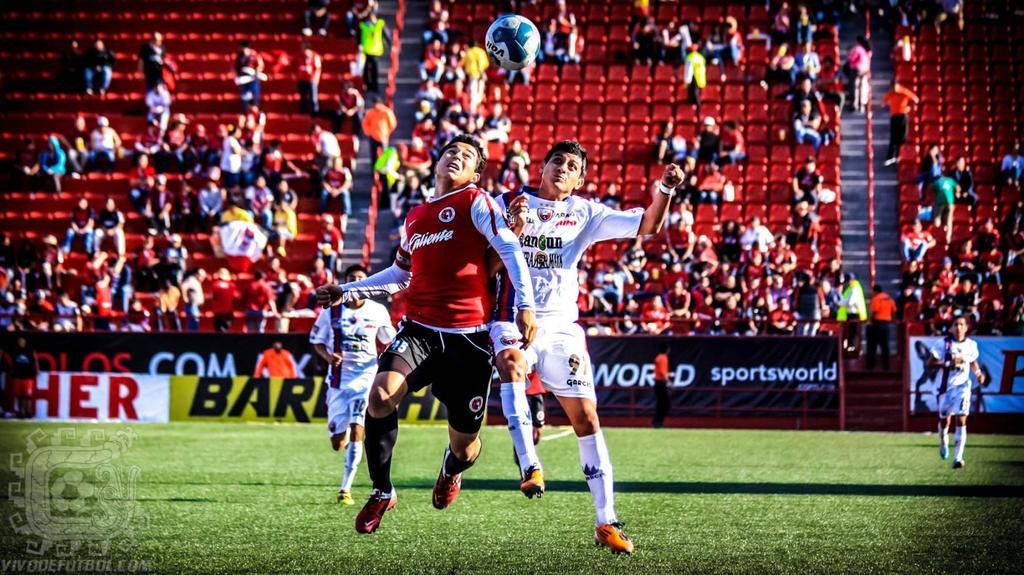<image>
Summarize the visual content of the image. Players playing soccer with fans watching and an advertisement about sportworld near the field. 